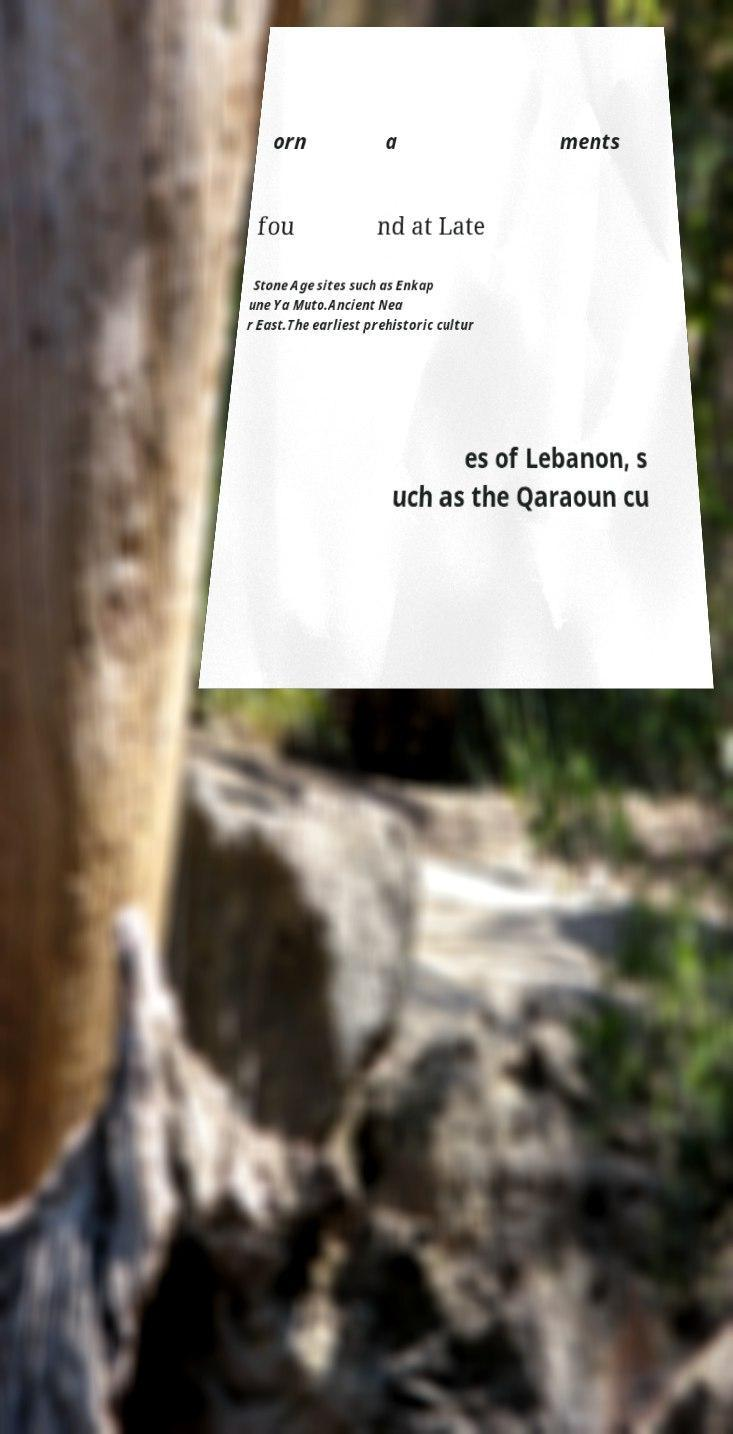For documentation purposes, I need the text within this image transcribed. Could you provide that? orn a ments fou nd at Late Stone Age sites such as Enkap une Ya Muto.Ancient Nea r East.The earliest prehistoric cultur es of Lebanon, s uch as the Qaraoun cu 